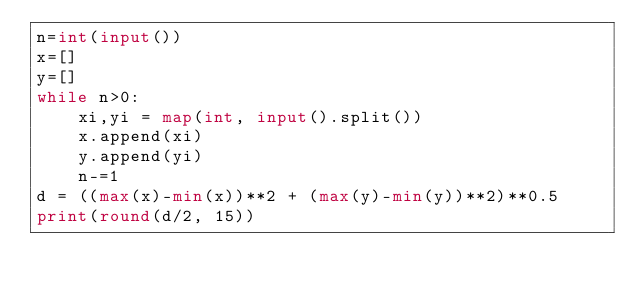Convert code to text. <code><loc_0><loc_0><loc_500><loc_500><_Python_>n=int(input())
x=[]
y=[]
while n>0:
    xi,yi = map(int, input().split())
    x.append(xi)
    y.append(yi)
    n-=1
d = ((max(x)-min(x))**2 + (max(y)-min(y))**2)**0.5
print(round(d/2, 15))</code> 